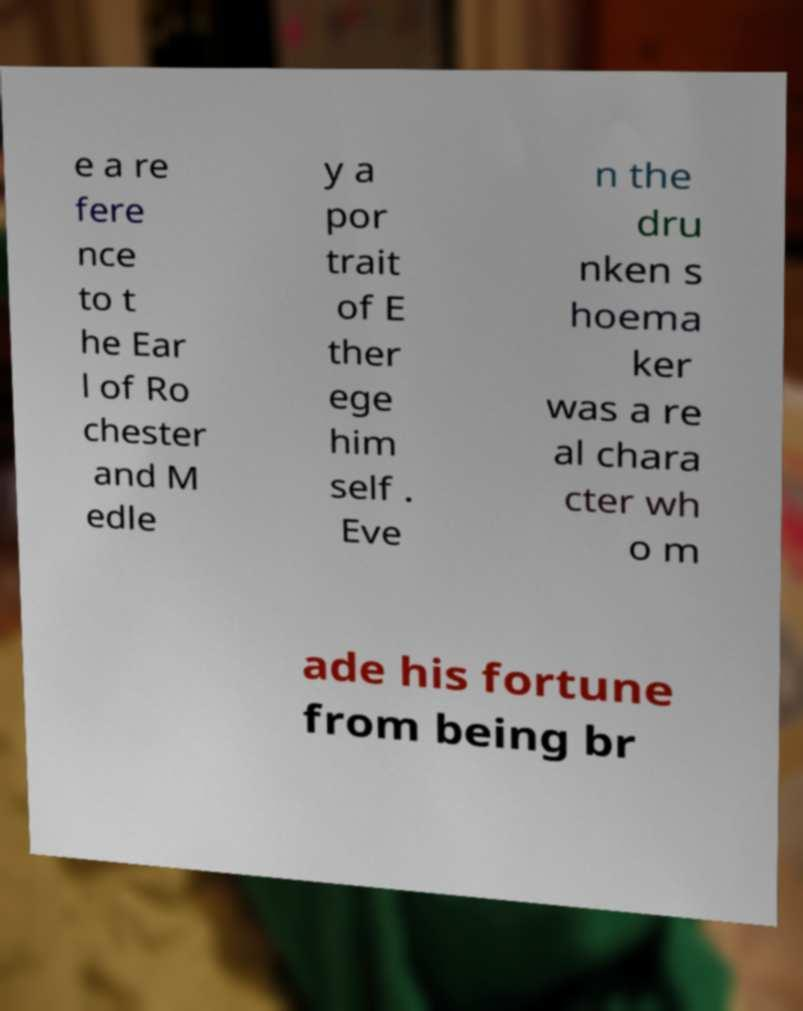Can you accurately transcribe the text from the provided image for me? e a re fere nce to t he Ear l of Ro chester and M edle y a por trait of E ther ege him self . Eve n the dru nken s hoema ker was a re al chara cter wh o m ade his fortune from being br 